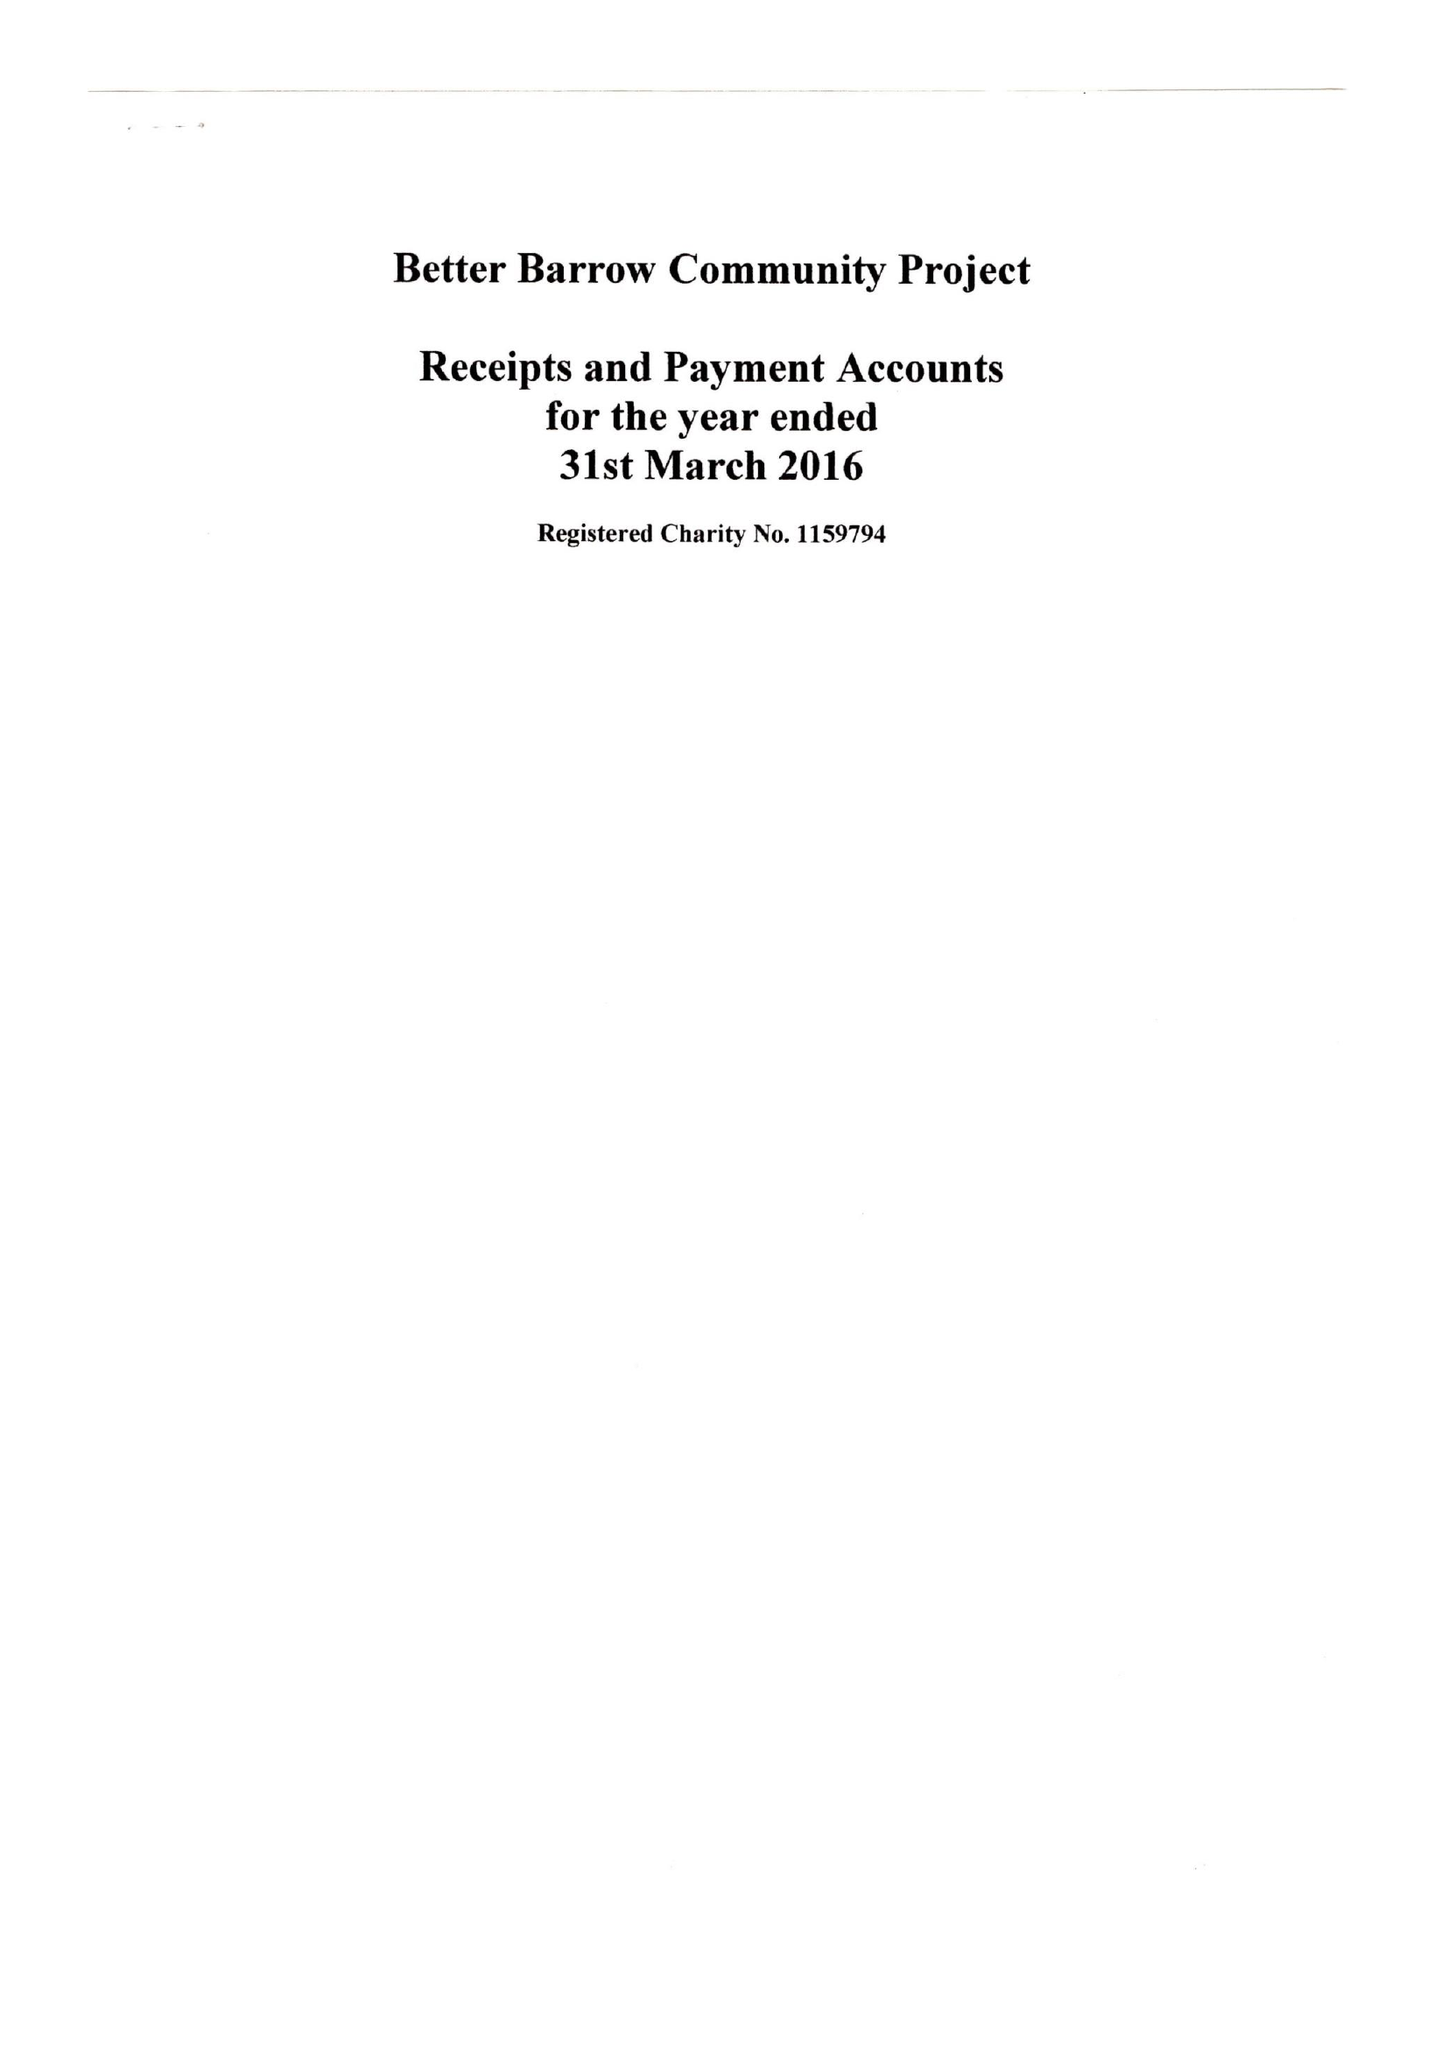What is the value for the address__postcode?
Answer the question using a single word or phrase. DN19 7AA 